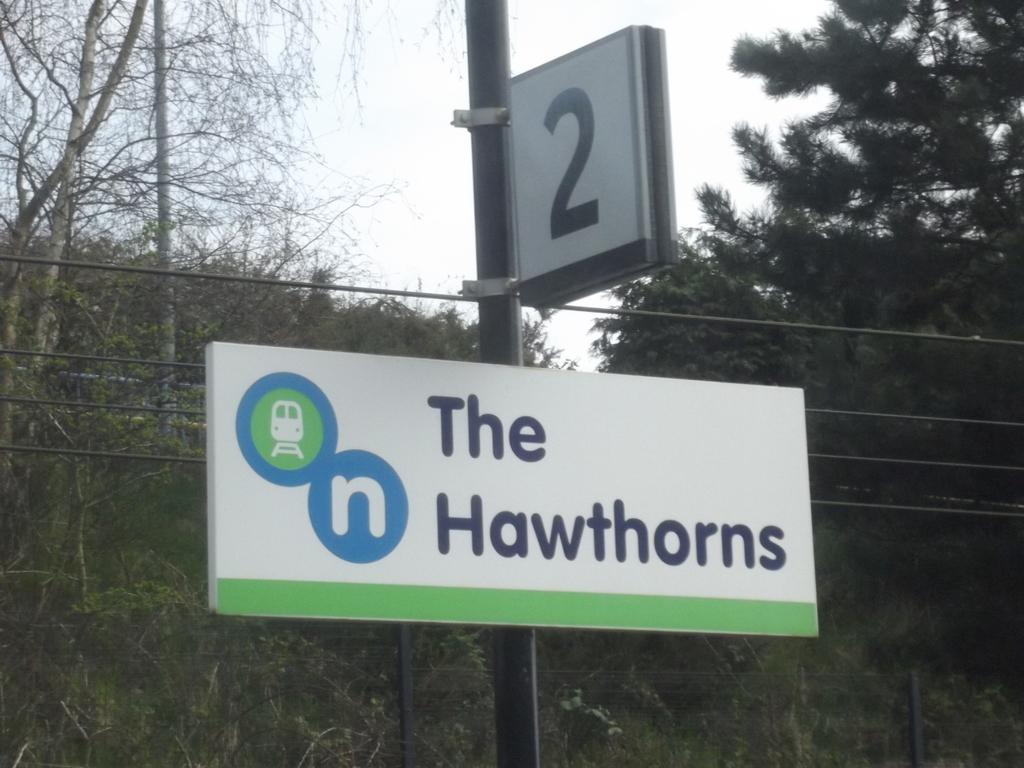Provide a one-sentence caption for the provided image. A sign with the number 2 on it above a sign with The Hawthorns on it. 